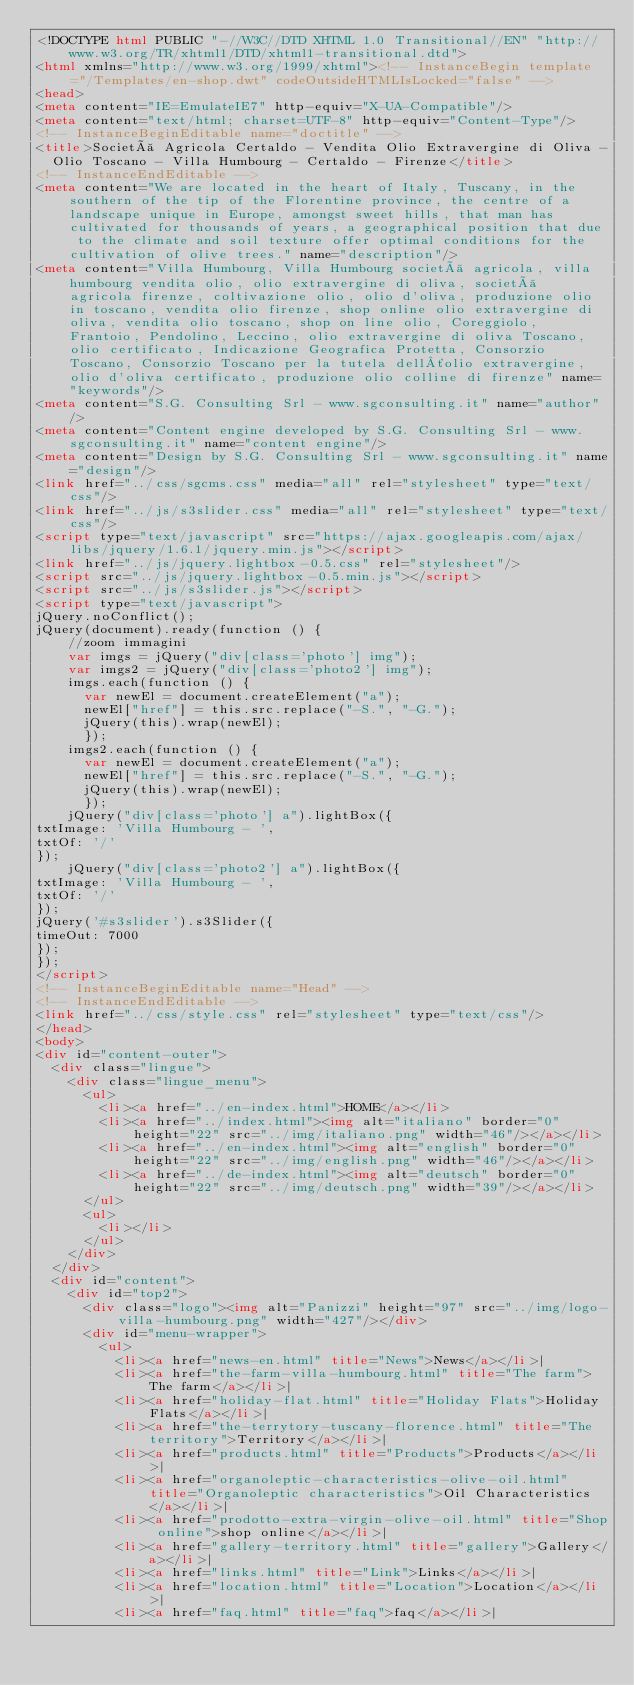Convert code to text. <code><loc_0><loc_0><loc_500><loc_500><_HTML_><!DOCTYPE html PUBLIC "-//W3C//DTD XHTML 1.0 Transitional//EN" "http://www.w3.org/TR/xhtml1/DTD/xhtml1-transitional.dtd">
<html xmlns="http://www.w3.org/1999/xhtml"><!-- InstanceBegin template="/Templates/en-shop.dwt" codeOutsideHTMLIsLocked="false" -->
<head>
<meta content="IE=EmulateIE7" http-equiv="X-UA-Compatible"/>
<meta content="text/html; charset=UTF-8" http-equiv="Content-Type"/>
<!-- InstanceBeginEditable name="doctitle" -->
<title>Società Agricola Certaldo - Vendita Olio Extravergine di Oliva -
  Olio Toscano - Villa Humbourg - Certaldo - Firenze</title>
<!-- InstanceEndEditable -->
<meta content="We are located in the heart of Italy, Tuscany, in the southern of the tip of the Florentine province, the centre of a landscape unique in Europe, amongst sweet hills, that man has cultivated for thousands of years, a geographical position that due to the climate and soil texture offer optimal conditions for the cultivation of olive trees." name="description"/>
<meta content="Villa Humbourg, Villa Humbourg società agricola, villa humbourg vendita olio, olio extravergine di oliva, società agricola firenze, coltivazione olio, olio d'oliva, produzione olio in toscano, vendita olio firenze, shop online olio extravergine di oliva, vendita olio toscano, shop on line olio, Coreggiolo, Frantoio, Pendolino, Leccino, olio extravergine di oliva Toscano, olio certificato, Indicazione Geografica Protetta, Consorzio Toscano, Consorzio Toscano per la tutela dell´olio extravergine, olio d'oliva certificato, produzione olio colline di firenze" name="keywords"/>
<meta content="S.G. Consulting Srl - www.sgconsulting.it" name="author"/>
<meta content="Content engine developed by S.G. Consulting Srl - www.sgconsulting.it" name="content engine"/>
<meta content="Design by S.G. Consulting Srl - www.sgconsulting.it" name="design"/>
<link href="../css/sgcms.css" media="all" rel="stylesheet" type="text/css"/>
<link href="../js/s3slider.css" media="all" rel="stylesheet" type="text/css"/>
<script type="text/javascript" src="https://ajax.googleapis.com/ajax/libs/jquery/1.6.1/jquery.min.js"></script>
<link href="../js/jquery.lightbox-0.5.css" rel="stylesheet"/>
<script src="../js/jquery.lightbox-0.5.min.js"></script>
<script src="../js/s3slider.js"></script>
<script type="text/javascript">
jQuery.noConflict();
jQuery(document).ready(function () {
    //zoom immagini
    var imgs = jQuery("div[class='photo'] img");
    var imgs2 = jQuery("div[class='photo2'] img");
    imgs.each(function () {
      var newEl = document.createElement("a");
      newEl["href"] = this.src.replace("-S.", "-G.");
      jQuery(this).wrap(newEl);
      });
    imgs2.each(function () {
      var newEl = document.createElement("a");
      newEl["href"] = this.src.replace("-S.", "-G.");
      jQuery(this).wrap(newEl);
      });
    jQuery("div[class='photo'] a").lightBox({
txtImage: 'Villa Humbourg - ',
txtOf: '/'
});
    jQuery("div[class='photo2'] a").lightBox({
txtImage: 'Villa Humbourg - ',
txtOf: '/'
});
jQuery('#s3slider').s3Slider({
timeOut: 7000
});
});
</script>
<!-- InstanceBeginEditable name="Head" -->
<!-- InstanceEndEditable -->
<link href="../css/style.css" rel="stylesheet" type="text/css"/>
</head>
<body>
<div id="content-outer">
  <div class="lingue">
    <div class="lingue_menu">
      <ul>
        <li><a href="../en-index.html">HOME</a></li>
        <li><a href="../index.html"><img alt="italiano" border="0" height="22" src="../img/italiano.png" width="46"/></a></li>
        <li><a href="../en-index.html"><img alt="english" border="0" height="22" src="../img/english.png" width="46"/></a></li>
        <li><a href="../de-index.html"><img alt="deutsch" border="0" height="22" src="../img/deutsch.png" width="39"/></a></li>
      </ul>
      <ul>
        <li></li>
      </ul>
    </div>
  </div>
  <div id="content">
    <div id="top2">
      <div class="logo"><img alt="Panizzi" height="97" src="../img/logo-villa-humbourg.png" width="427"/></div>
      <div id="menu-wrapper">
        <ul>
          <li><a href="news-en.html" title="News">News</a></li>|
          <li><a href="the-farm-villa-humbourg.html" title="The farm">The farm</a></li>|
          <li><a href="holiday-flat.html" title="Holiday Flats">Holiday Flats</a></li>|
          <li><a href="the-terrytory-tuscany-florence.html" title="The territory">Territory</a></li>|
          <li><a href="products.html" title="Products">Products</a></li>|
          <li><a href="organoleptic-characteristics-olive-oil.html" title="Organoleptic characteristics">Oil Characteristics</a></li>|
          <li><a href="prodotto-extra-virgin-olive-oil.html" title="Shop online">shop online</a></li>|
          <li><a href="gallery-territory.html" title="gallery">Gallery</a></li>|
          <li><a href="links.html" title="Link">Links</a></li>|
          <li><a href="location.html" title="Location">Location</a></li>|
          <li><a href="faq.html" title="faq">faq</a></li>|</code> 